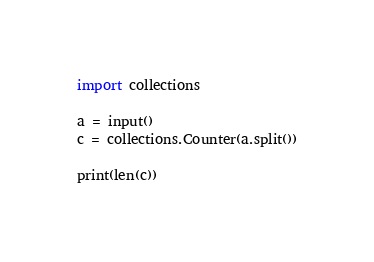Convert code to text. <code><loc_0><loc_0><loc_500><loc_500><_Python_>import collections

a = input()
c = collections.Counter(a.split())

print(len(c))
</code> 